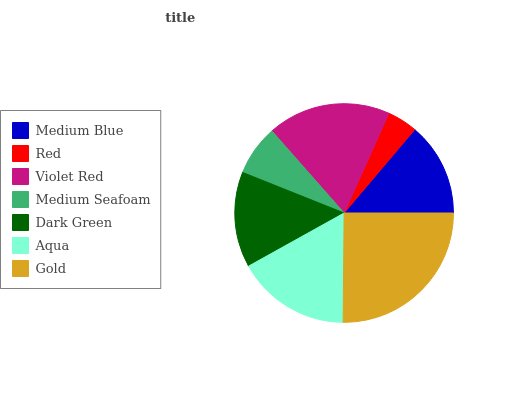Is Red the minimum?
Answer yes or no. Yes. Is Gold the maximum?
Answer yes or no. Yes. Is Violet Red the minimum?
Answer yes or no. No. Is Violet Red the maximum?
Answer yes or no. No. Is Violet Red greater than Red?
Answer yes or no. Yes. Is Red less than Violet Red?
Answer yes or no. Yes. Is Red greater than Violet Red?
Answer yes or no. No. Is Violet Red less than Red?
Answer yes or no. No. Is Dark Green the high median?
Answer yes or no. Yes. Is Dark Green the low median?
Answer yes or no. Yes. Is Medium Blue the high median?
Answer yes or no. No. Is Medium Blue the low median?
Answer yes or no. No. 